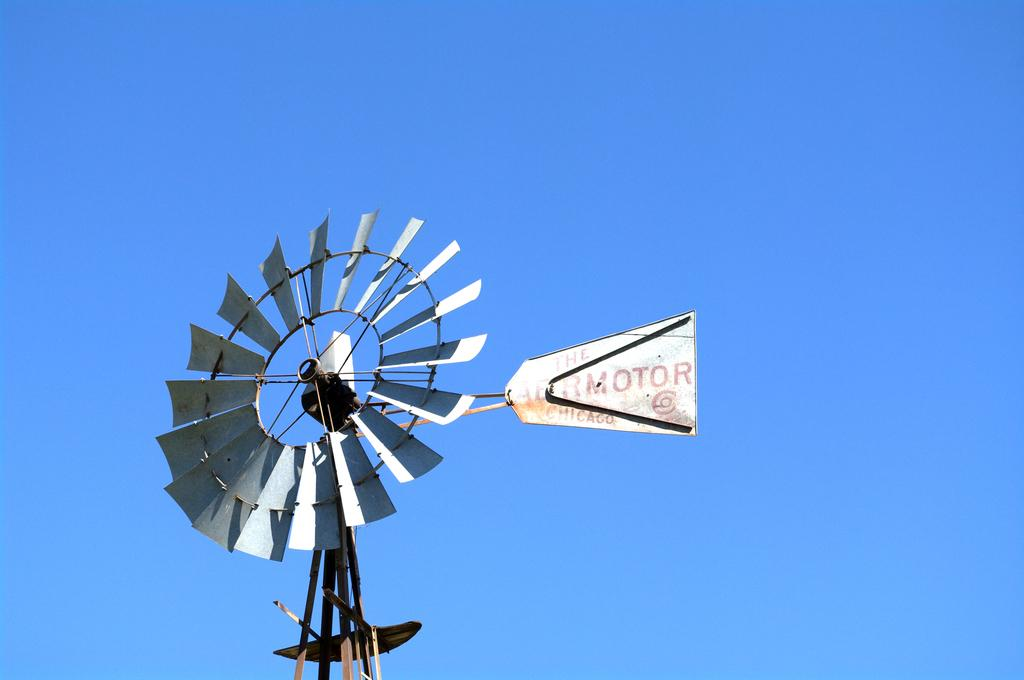What type of windmill is in the image? There is a water windmill in the image. What can be seen in the background of the image? The sky is visible in the background of the image. Where is the toy seashore located in the image? There is no toy seashore present in the image. What type of glue is used to hold the windmill together in the image? There is no glue mentioned or visible in the image; the windmill is a functioning structure. 